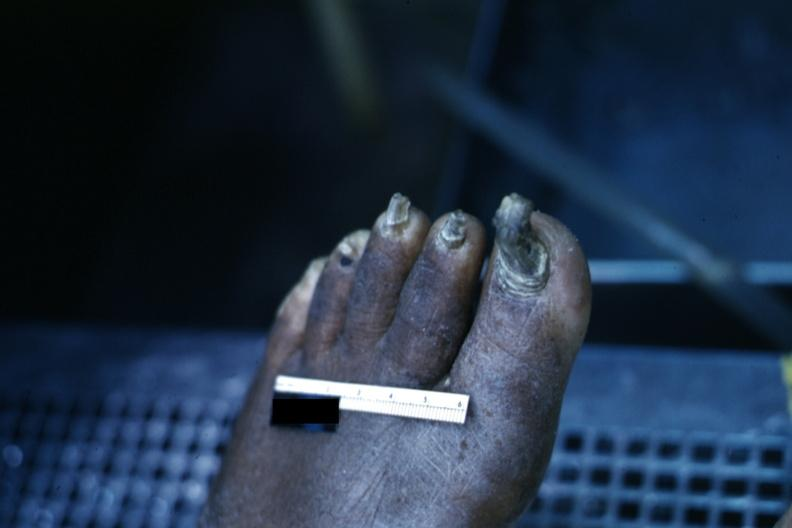what are present?
Answer the question using a single word or phrase. Extremities 